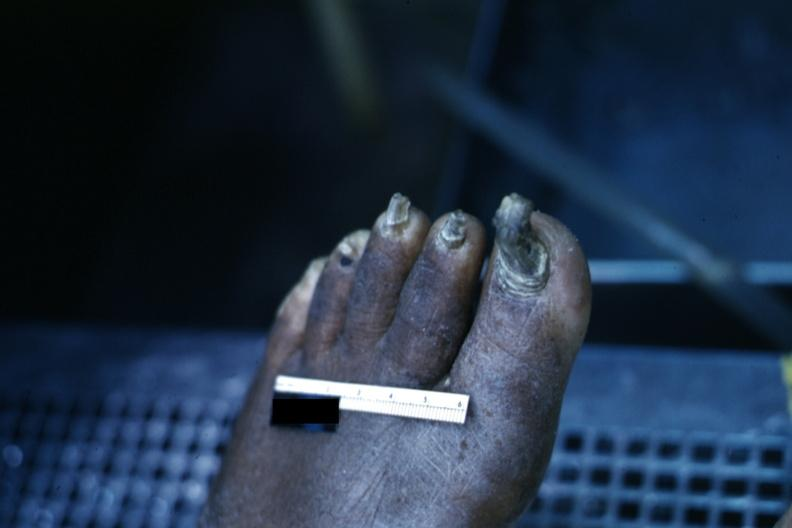what are present?
Answer the question using a single word or phrase. Extremities 